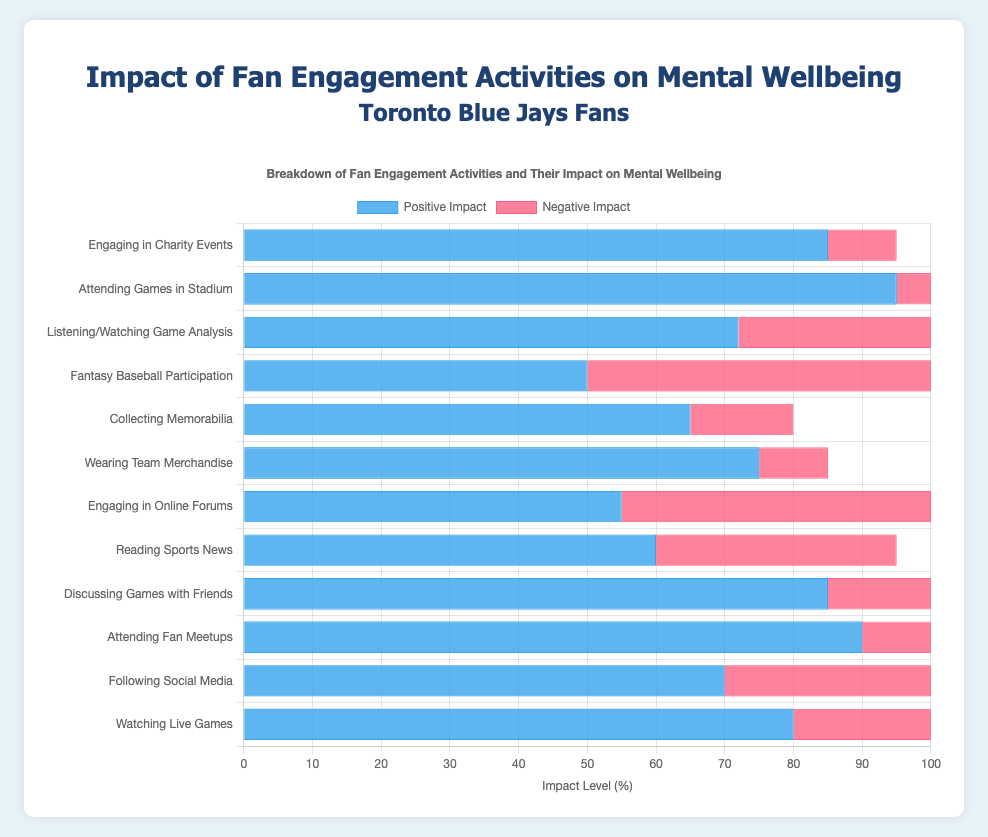What activity has the highest positive impact on mental well-being? The activity with the highest positive impact can be determined by looking at the bar that is the longest in the 'Positive Impact' dataset. Attending Games in Stadium has the highest positive impact with a value of 95.
Answer: Attending Games in Stadium Which activity has a higher negative impact: Following Social Media or Watching Live Games? To compare, you need to look at the 'Negative Impact' bars for both activities. Following Social Media has a negative impact of 50, while Watching Live Games has a negative impact of 40, so Following Social Media has a higher negative impact.
Answer: Following Social Media What is the average positive impact of the activities: Reading Sports News, Engaging in Online Forums, and Fantasy Baseball Participation? First, find the positive impacts for each activity: Reading Sports News (60), Engaging in Online Forums (55), and Fantasy Baseball Participation (50). Sum these values (60 + 55 + 50 = 165) and then divide by the number of activities (165 / 3). The average positive impact is 55.
Answer: 55 Which activity has the smallest difference between its positive and negative impacts? To find this, subtract the negative impact from the positive impact for each activity and find the smallest difference. Engaging in Charity Events has the smallest difference (85 - 10 = 75).
Answer: Engaging in Charity Events How many activities have a positive impact greater than 70? Count the number of activities where the 'Positive Impact' value is greater than 70. There are seven such activities: Watching Live Games, Following Social Media, Attending Fan Meetups, Discussing Games with Friends, Wearing Team Merchandise, Listening/Watching Game Analysis, and Attending Games in Stadium.
Answer: 7 Which activity has a higher total impact (sum of positive and negative) than Engaging in Online Forums? First, calculate the total impact for Engaging in Online Forums (55 + 45 = 100). Then find activities with a total higher than 100. Activities are: Watching Live Games (80 + 40 = 120), Following Social Media (70 + 50 = 120), Attending Fan Meetups (90 + 20 = 110), Discussing Games with Friends (85 + 30 = 115), Reading Sports News (60 + 35 = 95; not higher), and Fantasy Baseball Participation (50 + 60 = 110).
Answer: 5 activities What is the difference in positive impacts between Engaging in Charity Events and Watching Live Games? Find the positive impacts of both activities: Engaging in Charity Events (85) and Watching Live Games (80). The difference is 85 - 80 = 5.
Answer: 5 